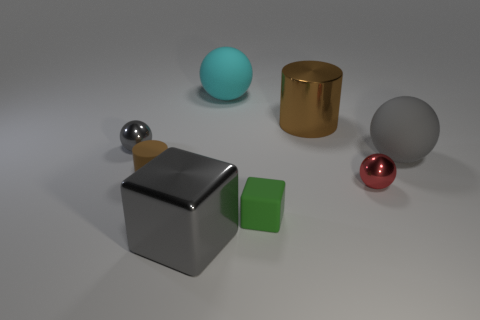Subtract all cyan spheres. How many spheres are left? 3 Subtract all cubes. How many objects are left? 6 Subtract 3 balls. How many balls are left? 1 Subtract all red balls. How many purple blocks are left? 0 Subtract all cubes. Subtract all large cyan things. How many objects are left? 5 Add 8 gray metallic spheres. How many gray metallic spheres are left? 9 Add 1 big cyan balls. How many big cyan balls exist? 2 Add 1 tiny brown cylinders. How many objects exist? 9 Subtract all gray blocks. How many blocks are left? 1 Subtract 0 purple spheres. How many objects are left? 8 